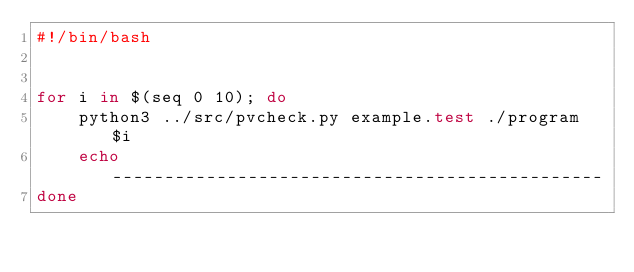Convert code to text. <code><loc_0><loc_0><loc_500><loc_500><_Bash_>#!/bin/bash


for i in $(seq 0 10); do
    python3 ../src/pvcheck.py example.test ./program $i
    echo -----------------------------------------------
done
</code> 